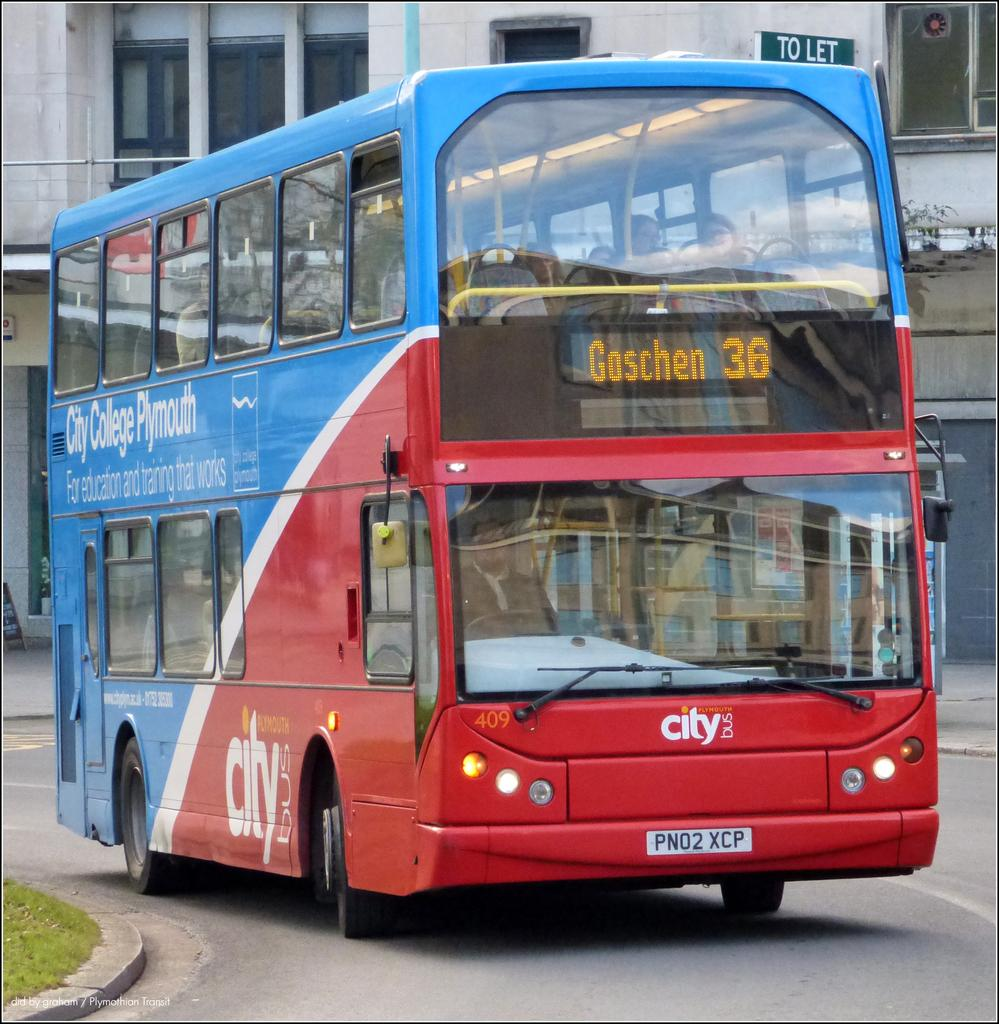<image>
Offer a succinct explanation of the picture presented. A double decker bus is on route 36 to Goschen. 